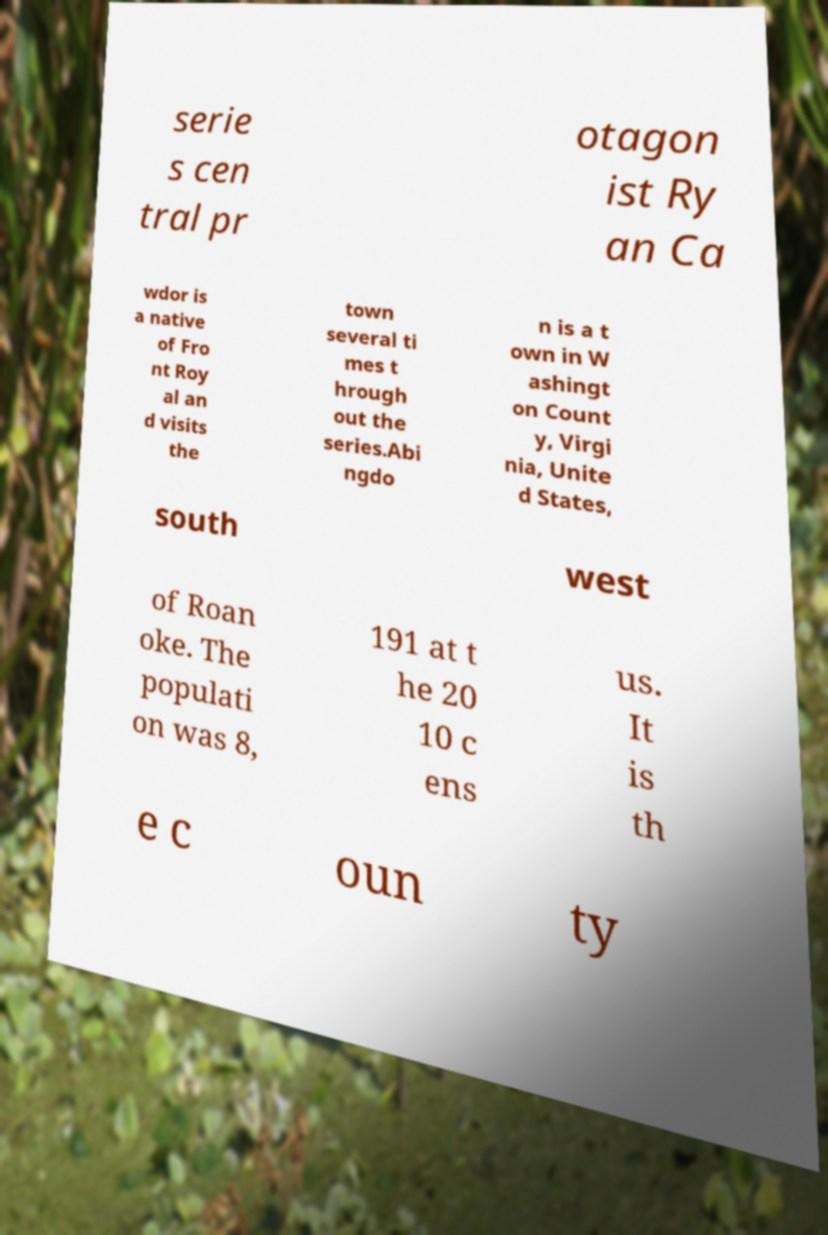What messages or text are displayed in this image? I need them in a readable, typed format. serie s cen tral pr otagon ist Ry an Ca wdor is a native of Fro nt Roy al an d visits the town several ti mes t hrough out the series.Abi ngdo n is a t own in W ashingt on Count y, Virgi nia, Unite d States, south west of Roan oke. The populati on was 8, 191 at t he 20 10 c ens us. It is th e c oun ty 